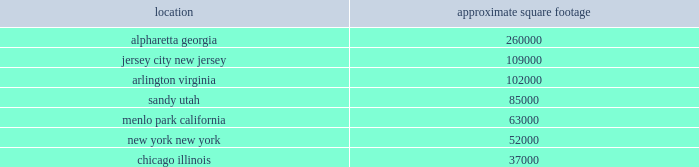Table of contents e*trade | 2016 10-k 24 2022 limits on the persons who may call special meetings of stockholders 2022 the prohibition of stockholder action by written consent 2022 advance notice requirements for nominations to the board or for proposing matters that can be acted on by stockholders at stockholder meetings in addition , certain provisions of our stock incentive plans , management retention and employment agreements ( including severance payments and stock option acceleration ) , our senior secured credit facility , certain provisions of delaware law and certain provisions of the indentures governing certain series of our debt securities that would require us to offer to purchase such securities at a premium in the event of certain changes in our ownership may also discourage , delay or prevent someone from acquiring or merging with us , which could limit the opportunity for our stockholders to receive a premium for their shares of our common stock and could also affect the price that some investors are willing to pay for our common stock .
Item 1b .
Unresolved staff comments item 2 .
Properties a summary of our significant locations at december 31 , 2016 is shown in the table .
Square footage amounts are net of space that has been sublet or space that is part of a facility restructuring. .
All facilities are leased at december 31 , 2016 .
All other leased facilities with space of less than 25000 square feet are not listed by location .
In addition to the significant facilities above , we also lease all 30 regional branches , ranging in space from approximately 2500 to 8000 square feet .
Item 3 .
Legal proceedings information in response to this item can be found under the heading legal matters in note 21 2014 commitments , contingencies and other regulatory matters in this annual report and is incorporated by reference into this item .
Item 4 .
Mine safety disclosures not applicable. .
At december 312016 what was the ratio of the square footage of alpharetta georgia to jersey city new jersey? 
Rationale: at december 312016 there was 2.39 square footage of alpharetta georgia for each square foot in jersey city new jersey
Computations: (260000 / 109000)
Answer: 2.38532. 